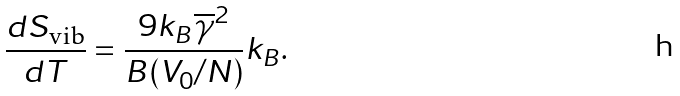<formula> <loc_0><loc_0><loc_500><loc_500>\frac { d S _ { \text {vib} } } { d T } = \frac { 9 k _ { B } \overline { \gamma } ^ { 2 } } { B ( V _ { 0 } / N ) } k _ { B } .</formula> 